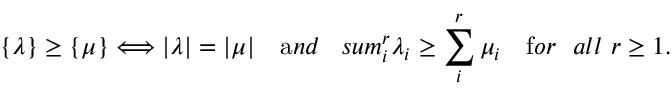Convert formula to latex. <formula><loc_0><loc_0><loc_500><loc_500>\{ \lambda \} \geq \{ \mu \} \Longleftrightarrow | \lambda | = | \mu | \quad { a n d } \quad , s u m _ { i } ^ { r } \lambda _ { i } \geq \sum _ { i } ^ { r } \mu _ { i } \quad { f o r \ \ a l l } \ r \geq 1 .</formula> 